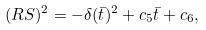Convert formula to latex. <formula><loc_0><loc_0><loc_500><loc_500>( R S ) ^ { 2 } = - \delta ( \bar { t } ) ^ { 2 } + c _ { 5 } \bar { t } + c _ { 6 } ,</formula> 